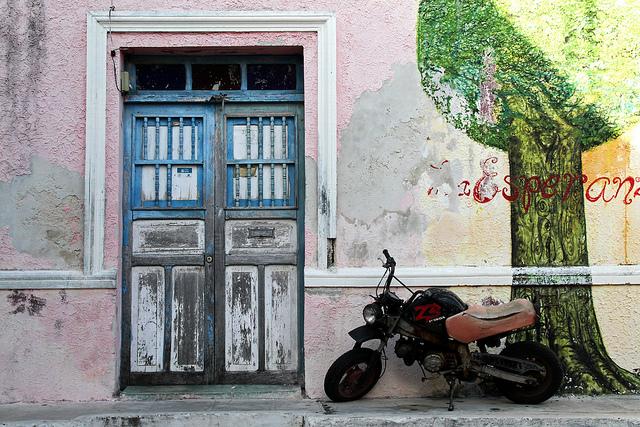What is leaning against the wall?
Short answer required. Motorcycle. Do the doors look like the need to be painted?
Short answer required. Yes. What is painted on the wall?
Be succinct. Tree. 